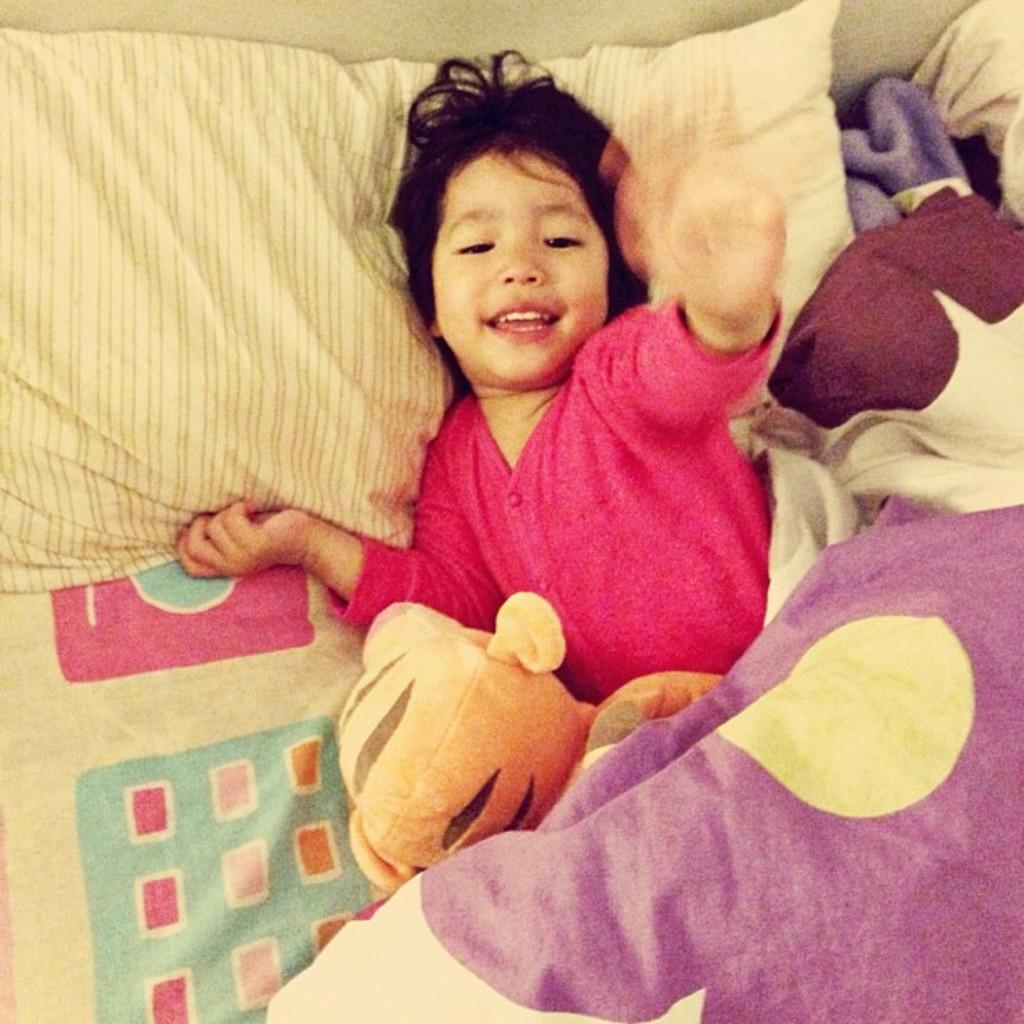What is the child doing in the image? The child is lying on the bed in the image. What is supporting the child's head in the image? There is a pillow in the image. What is covering the child in the image? There is a blanket in the image. What type of train can be seen in the image? There is no train present in the image; it features a child lying on a bed with a pillow and blanket. What toys is the child playing with in the image? There are no toys visible in the image; the child is simply lying on the bed with a pillow and blanket. 